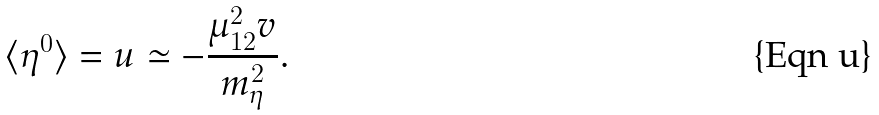Convert formula to latex. <formula><loc_0><loc_0><loc_500><loc_500>\langle \eta ^ { 0 } \rangle = u \simeq - { \frac { \mu _ { 1 2 } ^ { 2 } v } { m _ { \eta } ^ { 2 } } } .</formula> 